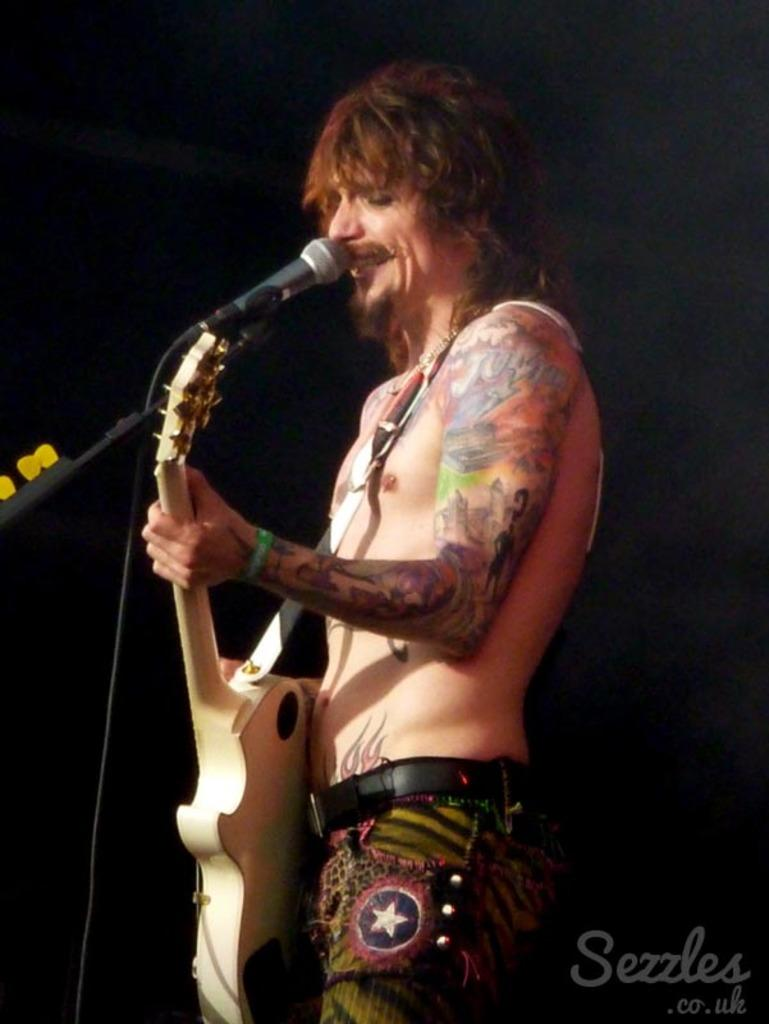What is the man in the image doing? The man is playing a guitar. What object is present in the image that is typically used for amplifying sound? There is a microphone in the image. What type of hot beverage is the man drinking while playing the guitar in the image? There is no hot beverage present in the image; the man is playing a guitar and there is a microphone nearby. How many horses are visible in the image? There are no horses present in the image. 